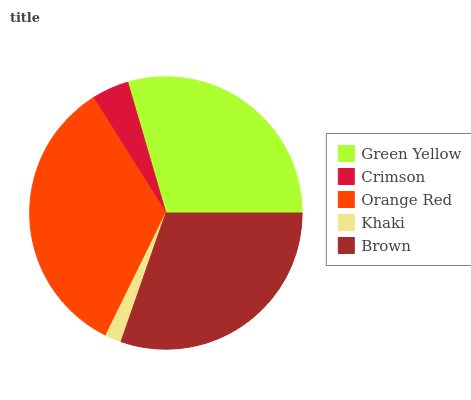Is Khaki the minimum?
Answer yes or no. Yes. Is Orange Red the maximum?
Answer yes or no. Yes. Is Crimson the minimum?
Answer yes or no. No. Is Crimson the maximum?
Answer yes or no. No. Is Green Yellow greater than Crimson?
Answer yes or no. Yes. Is Crimson less than Green Yellow?
Answer yes or no. Yes. Is Crimson greater than Green Yellow?
Answer yes or no. No. Is Green Yellow less than Crimson?
Answer yes or no. No. Is Green Yellow the high median?
Answer yes or no. Yes. Is Green Yellow the low median?
Answer yes or no. Yes. Is Crimson the high median?
Answer yes or no. No. Is Khaki the low median?
Answer yes or no. No. 